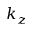<formula> <loc_0><loc_0><loc_500><loc_500>k _ { z }</formula> 